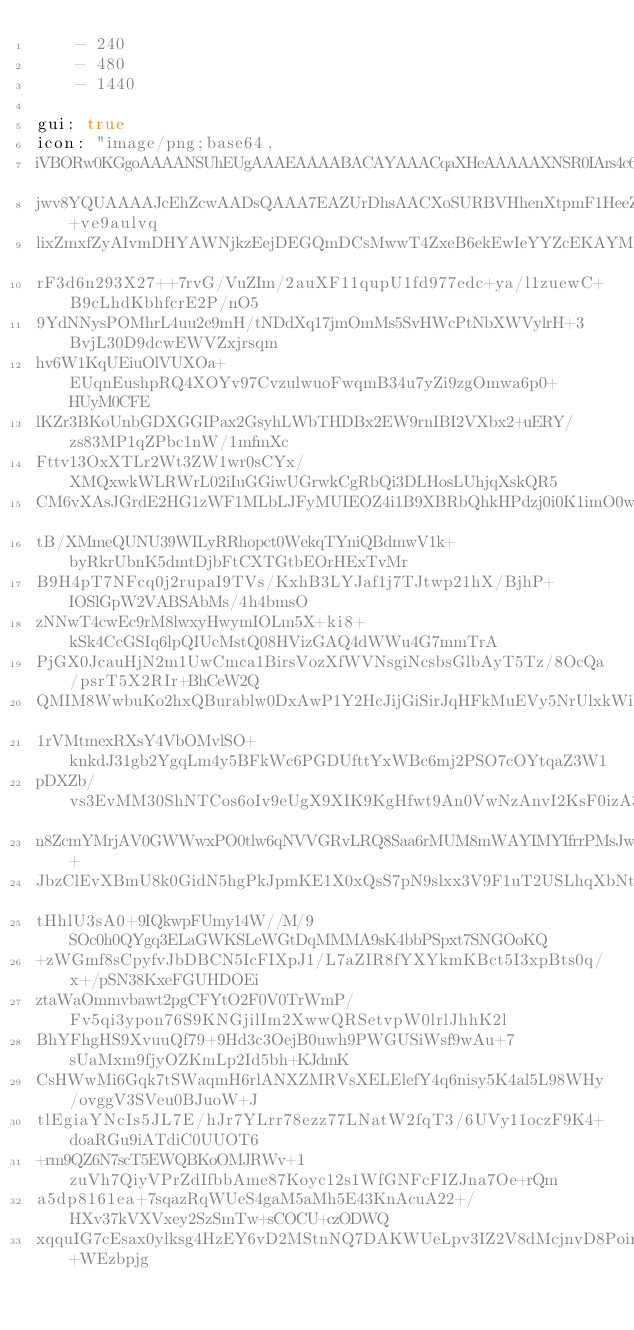Convert code to text. <code><loc_0><loc_0><loc_500><loc_500><_YAML_>    - 240
    - 480
    - 1440

gui: true
icon: "image/png;base64,
iVBORw0KGgoAAAANSUhEUgAAAEAAAABACAYAAACqaXHeAAAAAXNSR0IArs4c6QAAAARnQU1BAACx
jwv8YQUAAAAJcEhZcwAADsQAAA7EAZUrDhsAACXoSURBVHhenXtpmF1HeeZ793v73u6+ve9aulvq
lixZmxfZyAIvmDHYAWNjkzEejDEGQmDCsMwwT4ZxeB6ekEwIeYYZcEKAYMfGMUtsiwS8ybZ2I9va
rF3d6n293X27++7rvG/VuZIm/2auXF11qupU1fd977edc+ya/l1zuewC+B9cLhdKbhfcrE2P/nO5
9YdNNysPOMhrL4uu2e9mH/tNDdXq17jmOmMs5SvHWcPtNbXWVylrH+3BvjL30D9dcwEWVZxjrsqm
hv6W1KqUEiuOlVUXOa+EUqnEushpRQ4XOYv97CvzulwuoFwqmB34u7yZi9zgOmwa6p0+HUyM0CFE
lKZr3BKoUnbGDXGGIPax2GsyhLWbTHDBx2EW9rnIBI2VXbx2+uERY/zs83MP1qZPbc1nW/1mfmXc
Fttv13OxXTLr2Wt3ZW1wr0sCYx/XMQxwkWLRWrL02iIuGGiwUGrwkCgRbQi3DLHosLUhjqXskQR5
CM6vXAsJGrdE2HG1zWF1MLbLJFyMUIEOZ4i1B9XBRbQhkHPdzj0i0K1imO0wUmvpTNrP9OkerqO1
tB/XMmeQUNU39WILyRRhopct0WekqTYniQBdmwV1k+byRkrUbnK5dmtDjbFtCXTGtbEOrHExTvMr
B9H4pT7NFcq0j2rupaI9TVs/KxhB3LYJaf1j7TJtwp21hX/BjhP+IOSlGpW2VABSAbMs/4h4bmsO
zNNwT4cwEc9rM8lwxyHwymIOLm5X+ki8+kSk4CcGSIq6lpQIUcMstQ08HVizGAQ4dWWu4G7mmTrA
PjGX0JcauHjN2m1UwCmca1BirsVozXfWVNsgiNcsbsGlbAyT5Tz/8OcQa/psrT5X2RIr+BhCeW2Q
QMIM8WwbuKo2hxQBurablw0DxAwP1Y2HcJijGiSirJqHFkMuEVy5NrUlxkWiK2piGCaCnLUs07SO
1rVMtmexRXsY4VbOMvlSO+knkdJ31gb2YgqLm4y5BFkWc6PGDUfttYxWBc6mj2PSO7cOYtqaZ3W1
pDXZb/vs3EvMM30ShNTCos6oIv9eUgX9XIK9KgHfwt9An0VwNzAnvI2KsF0izA3kpRpFtpE3auBi
n8ZcmYMrjAV0GWWwxPO0tlw6qNVVGRvLRQ8Saa6rMUM8mWAYIMYIfrrPMsJwWUwy90oaMoiWaXa+
JbzClEvXBmU8k0GidN5hgPkJpmKE1X0xQsS7pN9slxx3V9F1uT2USLhqXbNtbQIZ8IX7qsVP7qPN
tHhlU3sA0+9IQkwpFUmy14W//M/9SOc0h0QYgq3ELaGWKSLeWGtDqMMMA9sK4bbPSpxt7SNGOoKQ
+zWGmf8sCpyfvJbDBCN5IcFIXpJ1/L7aZIR8fYXYkmKBct5I3xpBts0q/x+/pSN38KxeFGUHDOEi
ztaWaOmmvbawt2pgCFYtO2F0V0TrWmP/Fv5qi3ypon76S9KNGjilIm2XwwQRSetvpW0lrlJhhK2l
BhYFhgHS9XvuuQf79+9Hd3c3OejB0uwh9PWGUSiWsf9wAu+7sUaMxm9fjyOZKmLp2Id5bh+KJdmK
CsHWwMi6Gqk7tSWaqmH6rlANXZMRVsXELElefY4q6nisy5K4al5L98WHy/ovggV3SVeu0BJuoW+J
tlEgiaYNcIs5JL7E/hJr7YLrr78ezz77LNatW2fqT3/6UVy11oczF9K4+doaRGu9iATdiC0UUOT6
+rm9QZ6N7scT5EWQBKoOMJRWv+1zuVh7QiyVPrZdIfbbAme87Koyc12s1WfGNFcFIZJna7Oe+rQm
a5dp8161ea+7sqazRqWUeS4gaM5aMh5E43KnAcuA22+/HXv37kVXVxey2SzSmTw+sCOCU+czODWQ
xqquIG7cEsax0ylksg4HzEY6vD2MStnNQ7DAKWUeLpv3IZ2V8dMcjnvD8PoinGvnQ8Sb+WEzbpjg</code> 